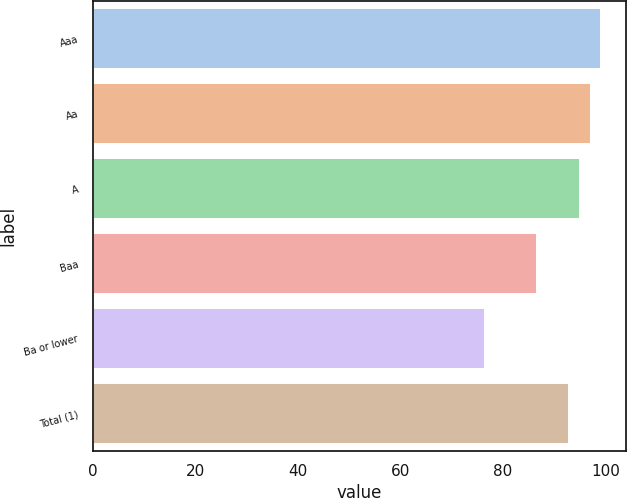Convert chart to OTSL. <chart><loc_0><loc_0><loc_500><loc_500><bar_chart><fcel>Aaa<fcel>Aa<fcel>A<fcel>Baa<fcel>Ba or lower<fcel>Total (1)<nl><fcel>98.97<fcel>96.88<fcel>94.79<fcel>86.5<fcel>76.3<fcel>92.7<nl></chart> 